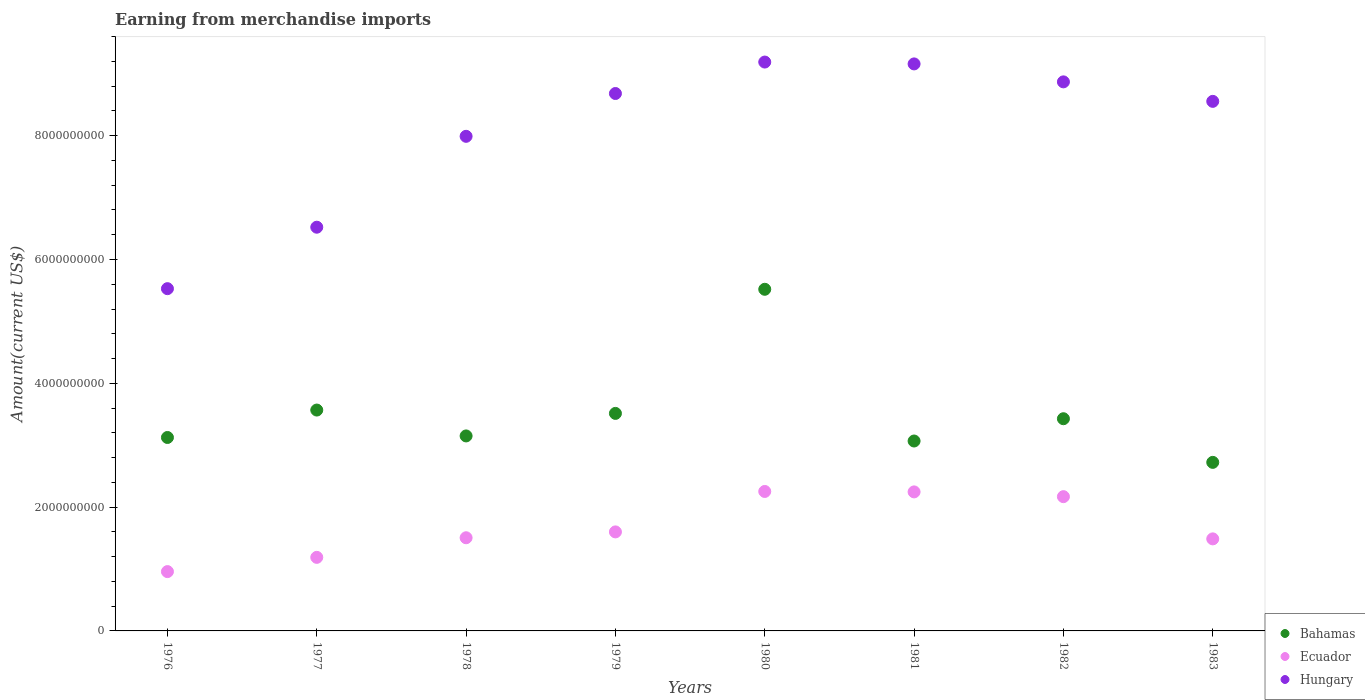What is the amount earned from merchandise imports in Ecuador in 1978?
Your response must be concise. 1.51e+09. Across all years, what is the maximum amount earned from merchandise imports in Hungary?
Offer a terse response. 9.19e+09. Across all years, what is the minimum amount earned from merchandise imports in Ecuador?
Provide a short and direct response. 9.58e+08. In which year was the amount earned from merchandise imports in Hungary maximum?
Your answer should be compact. 1980. In which year was the amount earned from merchandise imports in Hungary minimum?
Keep it short and to the point. 1976. What is the total amount earned from merchandise imports in Hungary in the graph?
Your answer should be very brief. 6.45e+1. What is the difference between the amount earned from merchandise imports in Hungary in 1979 and that in 1982?
Your answer should be very brief. -1.88e+08. What is the difference between the amount earned from merchandise imports in Ecuador in 1979 and the amount earned from merchandise imports in Hungary in 1983?
Your answer should be compact. -6.96e+09. What is the average amount earned from merchandise imports in Bahamas per year?
Ensure brevity in your answer.  3.51e+09. In the year 1979, what is the difference between the amount earned from merchandise imports in Ecuador and amount earned from merchandise imports in Bahamas?
Keep it short and to the point. -1.91e+09. In how many years, is the amount earned from merchandise imports in Ecuador greater than 4000000000 US$?
Ensure brevity in your answer.  0. What is the ratio of the amount earned from merchandise imports in Bahamas in 1980 to that in 1983?
Keep it short and to the point. 2.03. Is the amount earned from merchandise imports in Bahamas in 1976 less than that in 1983?
Your answer should be compact. No. Is the difference between the amount earned from merchandise imports in Ecuador in 1977 and 1978 greater than the difference between the amount earned from merchandise imports in Bahamas in 1977 and 1978?
Give a very brief answer. No. What is the difference between the highest and the second highest amount earned from merchandise imports in Hungary?
Your response must be concise. 3.00e+07. What is the difference between the highest and the lowest amount earned from merchandise imports in Hungary?
Ensure brevity in your answer.  3.66e+09. Is the sum of the amount earned from merchandise imports in Hungary in 1981 and 1983 greater than the maximum amount earned from merchandise imports in Ecuador across all years?
Your response must be concise. Yes. Is the amount earned from merchandise imports in Bahamas strictly less than the amount earned from merchandise imports in Hungary over the years?
Provide a short and direct response. Yes. How many dotlines are there?
Give a very brief answer. 3. What is the difference between two consecutive major ticks on the Y-axis?
Your response must be concise. 2.00e+09. Are the values on the major ticks of Y-axis written in scientific E-notation?
Provide a short and direct response. No. Where does the legend appear in the graph?
Your response must be concise. Bottom right. How are the legend labels stacked?
Provide a succinct answer. Vertical. What is the title of the graph?
Keep it short and to the point. Earning from merchandise imports. What is the label or title of the Y-axis?
Your answer should be compact. Amount(current US$). What is the Amount(current US$) of Bahamas in 1976?
Make the answer very short. 3.12e+09. What is the Amount(current US$) of Ecuador in 1976?
Make the answer very short. 9.58e+08. What is the Amount(current US$) in Hungary in 1976?
Give a very brief answer. 5.53e+09. What is the Amount(current US$) of Bahamas in 1977?
Your answer should be very brief. 3.57e+09. What is the Amount(current US$) of Ecuador in 1977?
Your answer should be very brief. 1.19e+09. What is the Amount(current US$) in Hungary in 1977?
Your answer should be compact. 6.52e+09. What is the Amount(current US$) in Bahamas in 1978?
Your response must be concise. 3.15e+09. What is the Amount(current US$) of Ecuador in 1978?
Give a very brief answer. 1.51e+09. What is the Amount(current US$) in Hungary in 1978?
Keep it short and to the point. 7.99e+09. What is the Amount(current US$) of Bahamas in 1979?
Keep it short and to the point. 3.51e+09. What is the Amount(current US$) of Ecuador in 1979?
Give a very brief answer. 1.60e+09. What is the Amount(current US$) of Hungary in 1979?
Ensure brevity in your answer.  8.68e+09. What is the Amount(current US$) of Bahamas in 1980?
Your answer should be compact. 5.52e+09. What is the Amount(current US$) in Ecuador in 1980?
Offer a terse response. 2.25e+09. What is the Amount(current US$) in Hungary in 1980?
Your response must be concise. 9.19e+09. What is the Amount(current US$) in Bahamas in 1981?
Ensure brevity in your answer.  3.07e+09. What is the Amount(current US$) in Ecuador in 1981?
Keep it short and to the point. 2.25e+09. What is the Amount(current US$) in Hungary in 1981?
Your answer should be compact. 9.16e+09. What is the Amount(current US$) in Bahamas in 1982?
Your answer should be compact. 3.43e+09. What is the Amount(current US$) of Ecuador in 1982?
Keep it short and to the point. 2.17e+09. What is the Amount(current US$) in Hungary in 1982?
Ensure brevity in your answer.  8.87e+09. What is the Amount(current US$) of Bahamas in 1983?
Offer a very short reply. 2.72e+09. What is the Amount(current US$) of Ecuador in 1983?
Your answer should be very brief. 1.49e+09. What is the Amount(current US$) of Hungary in 1983?
Offer a very short reply. 8.56e+09. Across all years, what is the maximum Amount(current US$) of Bahamas?
Your answer should be very brief. 5.52e+09. Across all years, what is the maximum Amount(current US$) in Ecuador?
Provide a short and direct response. 2.25e+09. Across all years, what is the maximum Amount(current US$) in Hungary?
Offer a terse response. 9.19e+09. Across all years, what is the minimum Amount(current US$) of Bahamas?
Ensure brevity in your answer.  2.72e+09. Across all years, what is the minimum Amount(current US$) of Ecuador?
Offer a terse response. 9.58e+08. Across all years, what is the minimum Amount(current US$) of Hungary?
Your answer should be very brief. 5.53e+09. What is the total Amount(current US$) in Bahamas in the graph?
Your answer should be compact. 2.81e+1. What is the total Amount(current US$) in Ecuador in the graph?
Make the answer very short. 1.34e+1. What is the total Amount(current US$) in Hungary in the graph?
Your response must be concise. 6.45e+1. What is the difference between the Amount(current US$) of Bahamas in 1976 and that in 1977?
Provide a short and direct response. -4.43e+08. What is the difference between the Amount(current US$) of Ecuador in 1976 and that in 1977?
Give a very brief answer. -2.30e+08. What is the difference between the Amount(current US$) of Hungary in 1976 and that in 1977?
Your answer should be compact. -9.93e+08. What is the difference between the Amount(current US$) of Bahamas in 1976 and that in 1978?
Give a very brief answer. -2.50e+07. What is the difference between the Amount(current US$) of Ecuador in 1976 and that in 1978?
Give a very brief answer. -5.47e+08. What is the difference between the Amount(current US$) of Hungary in 1976 and that in 1978?
Give a very brief answer. -2.46e+09. What is the difference between the Amount(current US$) of Bahamas in 1976 and that in 1979?
Your answer should be very brief. -3.89e+08. What is the difference between the Amount(current US$) in Ecuador in 1976 and that in 1979?
Make the answer very short. -6.41e+08. What is the difference between the Amount(current US$) of Hungary in 1976 and that in 1979?
Your answer should be compact. -3.15e+09. What is the difference between the Amount(current US$) of Bahamas in 1976 and that in 1980?
Make the answer very short. -2.39e+09. What is the difference between the Amount(current US$) in Ecuador in 1976 and that in 1980?
Make the answer very short. -1.29e+09. What is the difference between the Amount(current US$) in Hungary in 1976 and that in 1980?
Your answer should be very brief. -3.66e+09. What is the difference between the Amount(current US$) of Bahamas in 1976 and that in 1981?
Your answer should be very brief. 5.70e+07. What is the difference between the Amount(current US$) in Ecuador in 1976 and that in 1981?
Your response must be concise. -1.29e+09. What is the difference between the Amount(current US$) of Hungary in 1976 and that in 1981?
Provide a succinct answer. -3.63e+09. What is the difference between the Amount(current US$) of Bahamas in 1976 and that in 1982?
Offer a very short reply. -3.03e+08. What is the difference between the Amount(current US$) in Ecuador in 1976 and that in 1982?
Make the answer very short. -1.21e+09. What is the difference between the Amount(current US$) in Hungary in 1976 and that in 1982?
Offer a terse response. -3.34e+09. What is the difference between the Amount(current US$) in Bahamas in 1976 and that in 1983?
Ensure brevity in your answer.  4.02e+08. What is the difference between the Amount(current US$) of Ecuador in 1976 and that in 1983?
Your answer should be very brief. -5.29e+08. What is the difference between the Amount(current US$) of Hungary in 1976 and that in 1983?
Keep it short and to the point. -3.03e+09. What is the difference between the Amount(current US$) in Bahamas in 1977 and that in 1978?
Keep it short and to the point. 4.18e+08. What is the difference between the Amount(current US$) of Ecuador in 1977 and that in 1978?
Keep it short and to the point. -3.17e+08. What is the difference between the Amount(current US$) of Hungary in 1977 and that in 1978?
Keep it short and to the point. -1.47e+09. What is the difference between the Amount(current US$) of Bahamas in 1977 and that in 1979?
Offer a very short reply. 5.40e+07. What is the difference between the Amount(current US$) of Ecuador in 1977 and that in 1979?
Ensure brevity in your answer.  -4.11e+08. What is the difference between the Amount(current US$) in Hungary in 1977 and that in 1979?
Your response must be concise. -2.16e+09. What is the difference between the Amount(current US$) of Bahamas in 1977 and that in 1980?
Offer a terse response. -1.95e+09. What is the difference between the Amount(current US$) of Ecuador in 1977 and that in 1980?
Keep it short and to the point. -1.06e+09. What is the difference between the Amount(current US$) of Hungary in 1977 and that in 1980?
Offer a terse response. -2.67e+09. What is the difference between the Amount(current US$) of Ecuador in 1977 and that in 1981?
Your response must be concise. -1.06e+09. What is the difference between the Amount(current US$) of Hungary in 1977 and that in 1981?
Your answer should be very brief. -2.64e+09. What is the difference between the Amount(current US$) in Bahamas in 1977 and that in 1982?
Offer a very short reply. 1.40e+08. What is the difference between the Amount(current US$) of Ecuador in 1977 and that in 1982?
Give a very brief answer. -9.80e+08. What is the difference between the Amount(current US$) in Hungary in 1977 and that in 1982?
Your response must be concise. -2.35e+09. What is the difference between the Amount(current US$) in Bahamas in 1977 and that in 1983?
Your answer should be very brief. 8.45e+08. What is the difference between the Amount(current US$) of Ecuador in 1977 and that in 1983?
Keep it short and to the point. -2.98e+08. What is the difference between the Amount(current US$) in Hungary in 1977 and that in 1983?
Offer a very short reply. -2.03e+09. What is the difference between the Amount(current US$) in Bahamas in 1978 and that in 1979?
Keep it short and to the point. -3.64e+08. What is the difference between the Amount(current US$) in Ecuador in 1978 and that in 1979?
Offer a very short reply. -9.46e+07. What is the difference between the Amount(current US$) of Hungary in 1978 and that in 1979?
Provide a short and direct response. -6.92e+08. What is the difference between the Amount(current US$) of Bahamas in 1978 and that in 1980?
Make the answer very short. -2.37e+09. What is the difference between the Amount(current US$) of Ecuador in 1978 and that in 1980?
Provide a succinct answer. -7.48e+08. What is the difference between the Amount(current US$) of Hungary in 1978 and that in 1980?
Your response must be concise. -1.20e+09. What is the difference between the Amount(current US$) of Bahamas in 1978 and that in 1981?
Offer a terse response. 8.20e+07. What is the difference between the Amount(current US$) of Ecuador in 1978 and that in 1981?
Your answer should be compact. -7.41e+08. What is the difference between the Amount(current US$) in Hungary in 1978 and that in 1981?
Provide a short and direct response. -1.17e+09. What is the difference between the Amount(current US$) in Bahamas in 1978 and that in 1982?
Your answer should be compact. -2.78e+08. What is the difference between the Amount(current US$) in Ecuador in 1978 and that in 1982?
Give a very brief answer. -6.64e+08. What is the difference between the Amount(current US$) of Hungary in 1978 and that in 1982?
Provide a succinct answer. -8.80e+08. What is the difference between the Amount(current US$) in Bahamas in 1978 and that in 1983?
Ensure brevity in your answer.  4.27e+08. What is the difference between the Amount(current US$) of Ecuador in 1978 and that in 1983?
Keep it short and to the point. 1.81e+07. What is the difference between the Amount(current US$) in Hungary in 1978 and that in 1983?
Provide a succinct answer. -5.65e+08. What is the difference between the Amount(current US$) in Bahamas in 1979 and that in 1980?
Make the answer very short. -2.00e+09. What is the difference between the Amount(current US$) in Ecuador in 1979 and that in 1980?
Provide a succinct answer. -6.53e+08. What is the difference between the Amount(current US$) of Hungary in 1979 and that in 1980?
Make the answer very short. -5.08e+08. What is the difference between the Amount(current US$) in Bahamas in 1979 and that in 1981?
Your answer should be compact. 4.46e+08. What is the difference between the Amount(current US$) of Ecuador in 1979 and that in 1981?
Your answer should be very brief. -6.46e+08. What is the difference between the Amount(current US$) in Hungary in 1979 and that in 1981?
Your answer should be compact. -4.78e+08. What is the difference between the Amount(current US$) in Bahamas in 1979 and that in 1982?
Make the answer very short. 8.60e+07. What is the difference between the Amount(current US$) of Ecuador in 1979 and that in 1982?
Offer a terse response. -5.69e+08. What is the difference between the Amount(current US$) in Hungary in 1979 and that in 1982?
Make the answer very short. -1.88e+08. What is the difference between the Amount(current US$) in Bahamas in 1979 and that in 1983?
Your response must be concise. 7.91e+08. What is the difference between the Amount(current US$) of Ecuador in 1979 and that in 1983?
Your response must be concise. 1.13e+08. What is the difference between the Amount(current US$) in Hungary in 1979 and that in 1983?
Give a very brief answer. 1.27e+08. What is the difference between the Amount(current US$) in Bahamas in 1980 and that in 1981?
Provide a succinct answer. 2.45e+09. What is the difference between the Amount(current US$) of Hungary in 1980 and that in 1981?
Offer a very short reply. 3.00e+07. What is the difference between the Amount(current US$) of Bahamas in 1980 and that in 1982?
Make the answer very short. 2.09e+09. What is the difference between the Amount(current US$) in Ecuador in 1980 and that in 1982?
Offer a terse response. 8.40e+07. What is the difference between the Amount(current US$) of Hungary in 1980 and that in 1982?
Offer a very short reply. 3.20e+08. What is the difference between the Amount(current US$) in Bahamas in 1980 and that in 1983?
Your response must be concise. 2.80e+09. What is the difference between the Amount(current US$) of Ecuador in 1980 and that in 1983?
Provide a short and direct response. 7.66e+08. What is the difference between the Amount(current US$) of Hungary in 1980 and that in 1983?
Your answer should be very brief. 6.35e+08. What is the difference between the Amount(current US$) in Bahamas in 1981 and that in 1982?
Offer a terse response. -3.60e+08. What is the difference between the Amount(current US$) of Ecuador in 1981 and that in 1982?
Offer a terse response. 7.70e+07. What is the difference between the Amount(current US$) of Hungary in 1981 and that in 1982?
Your answer should be compact. 2.90e+08. What is the difference between the Amount(current US$) in Bahamas in 1981 and that in 1983?
Offer a very short reply. 3.45e+08. What is the difference between the Amount(current US$) of Ecuador in 1981 and that in 1983?
Ensure brevity in your answer.  7.59e+08. What is the difference between the Amount(current US$) of Hungary in 1981 and that in 1983?
Your answer should be compact. 6.05e+08. What is the difference between the Amount(current US$) in Bahamas in 1982 and that in 1983?
Your answer should be very brief. 7.05e+08. What is the difference between the Amount(current US$) in Ecuador in 1982 and that in 1983?
Offer a very short reply. 6.82e+08. What is the difference between the Amount(current US$) in Hungary in 1982 and that in 1983?
Your answer should be compact. 3.15e+08. What is the difference between the Amount(current US$) in Bahamas in 1976 and the Amount(current US$) in Ecuador in 1977?
Your response must be concise. 1.94e+09. What is the difference between the Amount(current US$) in Bahamas in 1976 and the Amount(current US$) in Hungary in 1977?
Make the answer very short. -3.40e+09. What is the difference between the Amount(current US$) in Ecuador in 1976 and the Amount(current US$) in Hungary in 1977?
Your answer should be very brief. -5.56e+09. What is the difference between the Amount(current US$) of Bahamas in 1976 and the Amount(current US$) of Ecuador in 1978?
Keep it short and to the point. 1.62e+09. What is the difference between the Amount(current US$) of Bahamas in 1976 and the Amount(current US$) of Hungary in 1978?
Your answer should be very brief. -4.87e+09. What is the difference between the Amount(current US$) in Ecuador in 1976 and the Amount(current US$) in Hungary in 1978?
Keep it short and to the point. -7.03e+09. What is the difference between the Amount(current US$) of Bahamas in 1976 and the Amount(current US$) of Ecuador in 1979?
Make the answer very short. 1.53e+09. What is the difference between the Amount(current US$) in Bahamas in 1976 and the Amount(current US$) in Hungary in 1979?
Offer a very short reply. -5.56e+09. What is the difference between the Amount(current US$) in Ecuador in 1976 and the Amount(current US$) in Hungary in 1979?
Provide a succinct answer. -7.72e+09. What is the difference between the Amount(current US$) in Bahamas in 1976 and the Amount(current US$) in Ecuador in 1980?
Provide a succinct answer. 8.72e+08. What is the difference between the Amount(current US$) of Bahamas in 1976 and the Amount(current US$) of Hungary in 1980?
Your answer should be very brief. -6.06e+09. What is the difference between the Amount(current US$) of Ecuador in 1976 and the Amount(current US$) of Hungary in 1980?
Your answer should be very brief. -8.23e+09. What is the difference between the Amount(current US$) in Bahamas in 1976 and the Amount(current US$) in Ecuador in 1981?
Give a very brief answer. 8.79e+08. What is the difference between the Amount(current US$) in Bahamas in 1976 and the Amount(current US$) in Hungary in 1981?
Provide a short and direct response. -6.04e+09. What is the difference between the Amount(current US$) in Ecuador in 1976 and the Amount(current US$) in Hungary in 1981?
Provide a short and direct response. -8.20e+09. What is the difference between the Amount(current US$) in Bahamas in 1976 and the Amount(current US$) in Ecuador in 1982?
Your answer should be compact. 9.56e+08. What is the difference between the Amount(current US$) in Bahamas in 1976 and the Amount(current US$) in Hungary in 1982?
Your answer should be compact. -5.74e+09. What is the difference between the Amount(current US$) of Ecuador in 1976 and the Amount(current US$) of Hungary in 1982?
Make the answer very short. -7.91e+09. What is the difference between the Amount(current US$) in Bahamas in 1976 and the Amount(current US$) in Ecuador in 1983?
Ensure brevity in your answer.  1.64e+09. What is the difference between the Amount(current US$) in Bahamas in 1976 and the Amount(current US$) in Hungary in 1983?
Make the answer very short. -5.43e+09. What is the difference between the Amount(current US$) in Ecuador in 1976 and the Amount(current US$) in Hungary in 1983?
Your answer should be very brief. -7.60e+09. What is the difference between the Amount(current US$) of Bahamas in 1977 and the Amount(current US$) of Ecuador in 1978?
Provide a short and direct response. 2.06e+09. What is the difference between the Amount(current US$) of Bahamas in 1977 and the Amount(current US$) of Hungary in 1978?
Ensure brevity in your answer.  -4.42e+09. What is the difference between the Amount(current US$) of Ecuador in 1977 and the Amount(current US$) of Hungary in 1978?
Offer a very short reply. -6.80e+09. What is the difference between the Amount(current US$) of Bahamas in 1977 and the Amount(current US$) of Ecuador in 1979?
Provide a short and direct response. 1.97e+09. What is the difference between the Amount(current US$) in Bahamas in 1977 and the Amount(current US$) in Hungary in 1979?
Ensure brevity in your answer.  -5.11e+09. What is the difference between the Amount(current US$) of Ecuador in 1977 and the Amount(current US$) of Hungary in 1979?
Make the answer very short. -7.49e+09. What is the difference between the Amount(current US$) of Bahamas in 1977 and the Amount(current US$) of Ecuador in 1980?
Your answer should be very brief. 1.32e+09. What is the difference between the Amount(current US$) of Bahamas in 1977 and the Amount(current US$) of Hungary in 1980?
Your response must be concise. -5.62e+09. What is the difference between the Amount(current US$) of Ecuador in 1977 and the Amount(current US$) of Hungary in 1980?
Keep it short and to the point. -8.00e+09. What is the difference between the Amount(current US$) of Bahamas in 1977 and the Amount(current US$) of Ecuador in 1981?
Your answer should be very brief. 1.32e+09. What is the difference between the Amount(current US$) of Bahamas in 1977 and the Amount(current US$) of Hungary in 1981?
Ensure brevity in your answer.  -5.59e+09. What is the difference between the Amount(current US$) of Ecuador in 1977 and the Amount(current US$) of Hungary in 1981?
Make the answer very short. -7.97e+09. What is the difference between the Amount(current US$) in Bahamas in 1977 and the Amount(current US$) in Ecuador in 1982?
Provide a short and direct response. 1.40e+09. What is the difference between the Amount(current US$) in Bahamas in 1977 and the Amount(current US$) in Hungary in 1982?
Your answer should be very brief. -5.30e+09. What is the difference between the Amount(current US$) in Ecuador in 1977 and the Amount(current US$) in Hungary in 1982?
Make the answer very short. -7.68e+09. What is the difference between the Amount(current US$) of Bahamas in 1977 and the Amount(current US$) of Ecuador in 1983?
Provide a short and direct response. 2.08e+09. What is the difference between the Amount(current US$) in Bahamas in 1977 and the Amount(current US$) in Hungary in 1983?
Ensure brevity in your answer.  -4.99e+09. What is the difference between the Amount(current US$) of Ecuador in 1977 and the Amount(current US$) of Hungary in 1983?
Make the answer very short. -7.37e+09. What is the difference between the Amount(current US$) in Bahamas in 1978 and the Amount(current US$) in Ecuador in 1979?
Your answer should be very brief. 1.55e+09. What is the difference between the Amount(current US$) in Bahamas in 1978 and the Amount(current US$) in Hungary in 1979?
Provide a succinct answer. -5.53e+09. What is the difference between the Amount(current US$) of Ecuador in 1978 and the Amount(current US$) of Hungary in 1979?
Ensure brevity in your answer.  -7.18e+09. What is the difference between the Amount(current US$) in Bahamas in 1978 and the Amount(current US$) in Ecuador in 1980?
Offer a terse response. 8.97e+08. What is the difference between the Amount(current US$) of Bahamas in 1978 and the Amount(current US$) of Hungary in 1980?
Provide a short and direct response. -6.04e+09. What is the difference between the Amount(current US$) of Ecuador in 1978 and the Amount(current US$) of Hungary in 1980?
Provide a short and direct response. -7.68e+09. What is the difference between the Amount(current US$) of Bahamas in 1978 and the Amount(current US$) of Ecuador in 1981?
Keep it short and to the point. 9.04e+08. What is the difference between the Amount(current US$) in Bahamas in 1978 and the Amount(current US$) in Hungary in 1981?
Make the answer very short. -6.01e+09. What is the difference between the Amount(current US$) of Ecuador in 1978 and the Amount(current US$) of Hungary in 1981?
Provide a succinct answer. -7.65e+09. What is the difference between the Amount(current US$) of Bahamas in 1978 and the Amount(current US$) of Ecuador in 1982?
Give a very brief answer. 9.81e+08. What is the difference between the Amount(current US$) of Bahamas in 1978 and the Amount(current US$) of Hungary in 1982?
Your response must be concise. -5.72e+09. What is the difference between the Amount(current US$) in Ecuador in 1978 and the Amount(current US$) in Hungary in 1982?
Your answer should be compact. -7.36e+09. What is the difference between the Amount(current US$) of Bahamas in 1978 and the Amount(current US$) of Ecuador in 1983?
Offer a very short reply. 1.66e+09. What is the difference between the Amount(current US$) of Bahamas in 1978 and the Amount(current US$) of Hungary in 1983?
Provide a succinct answer. -5.40e+09. What is the difference between the Amount(current US$) in Ecuador in 1978 and the Amount(current US$) in Hungary in 1983?
Provide a succinct answer. -7.05e+09. What is the difference between the Amount(current US$) in Bahamas in 1979 and the Amount(current US$) in Ecuador in 1980?
Provide a short and direct response. 1.26e+09. What is the difference between the Amount(current US$) in Bahamas in 1979 and the Amount(current US$) in Hungary in 1980?
Your response must be concise. -5.68e+09. What is the difference between the Amount(current US$) of Ecuador in 1979 and the Amount(current US$) of Hungary in 1980?
Your answer should be very brief. -7.59e+09. What is the difference between the Amount(current US$) in Bahamas in 1979 and the Amount(current US$) in Ecuador in 1981?
Your answer should be very brief. 1.27e+09. What is the difference between the Amount(current US$) of Bahamas in 1979 and the Amount(current US$) of Hungary in 1981?
Provide a succinct answer. -5.65e+09. What is the difference between the Amount(current US$) in Ecuador in 1979 and the Amount(current US$) in Hungary in 1981?
Make the answer very short. -7.56e+09. What is the difference between the Amount(current US$) in Bahamas in 1979 and the Amount(current US$) in Ecuador in 1982?
Provide a short and direct response. 1.34e+09. What is the difference between the Amount(current US$) of Bahamas in 1979 and the Amount(current US$) of Hungary in 1982?
Keep it short and to the point. -5.36e+09. What is the difference between the Amount(current US$) in Ecuador in 1979 and the Amount(current US$) in Hungary in 1982?
Keep it short and to the point. -7.27e+09. What is the difference between the Amount(current US$) in Bahamas in 1979 and the Amount(current US$) in Ecuador in 1983?
Make the answer very short. 2.03e+09. What is the difference between the Amount(current US$) of Bahamas in 1979 and the Amount(current US$) of Hungary in 1983?
Ensure brevity in your answer.  -5.04e+09. What is the difference between the Amount(current US$) in Ecuador in 1979 and the Amount(current US$) in Hungary in 1983?
Your answer should be compact. -6.96e+09. What is the difference between the Amount(current US$) in Bahamas in 1980 and the Amount(current US$) in Ecuador in 1981?
Offer a terse response. 3.27e+09. What is the difference between the Amount(current US$) of Bahamas in 1980 and the Amount(current US$) of Hungary in 1981?
Make the answer very short. -3.64e+09. What is the difference between the Amount(current US$) of Ecuador in 1980 and the Amount(current US$) of Hungary in 1981?
Offer a terse response. -6.91e+09. What is the difference between the Amount(current US$) of Bahamas in 1980 and the Amount(current US$) of Ecuador in 1982?
Offer a terse response. 3.35e+09. What is the difference between the Amount(current US$) in Bahamas in 1980 and the Amount(current US$) in Hungary in 1982?
Ensure brevity in your answer.  -3.35e+09. What is the difference between the Amount(current US$) in Ecuador in 1980 and the Amount(current US$) in Hungary in 1982?
Make the answer very short. -6.62e+09. What is the difference between the Amount(current US$) of Bahamas in 1980 and the Amount(current US$) of Ecuador in 1983?
Ensure brevity in your answer.  4.03e+09. What is the difference between the Amount(current US$) of Bahamas in 1980 and the Amount(current US$) of Hungary in 1983?
Your response must be concise. -3.04e+09. What is the difference between the Amount(current US$) of Ecuador in 1980 and the Amount(current US$) of Hungary in 1983?
Offer a very short reply. -6.30e+09. What is the difference between the Amount(current US$) of Bahamas in 1981 and the Amount(current US$) of Ecuador in 1982?
Make the answer very short. 8.99e+08. What is the difference between the Amount(current US$) of Bahamas in 1981 and the Amount(current US$) of Hungary in 1982?
Offer a very short reply. -5.80e+09. What is the difference between the Amount(current US$) in Ecuador in 1981 and the Amount(current US$) in Hungary in 1982?
Provide a succinct answer. -6.62e+09. What is the difference between the Amount(current US$) of Bahamas in 1981 and the Amount(current US$) of Ecuador in 1983?
Ensure brevity in your answer.  1.58e+09. What is the difference between the Amount(current US$) in Bahamas in 1981 and the Amount(current US$) in Hungary in 1983?
Offer a terse response. -5.49e+09. What is the difference between the Amount(current US$) of Ecuador in 1981 and the Amount(current US$) of Hungary in 1983?
Provide a short and direct response. -6.31e+09. What is the difference between the Amount(current US$) in Bahamas in 1982 and the Amount(current US$) in Ecuador in 1983?
Your answer should be very brief. 1.94e+09. What is the difference between the Amount(current US$) in Bahamas in 1982 and the Amount(current US$) in Hungary in 1983?
Provide a succinct answer. -5.13e+09. What is the difference between the Amount(current US$) in Ecuador in 1982 and the Amount(current US$) in Hungary in 1983?
Give a very brief answer. -6.39e+09. What is the average Amount(current US$) in Bahamas per year?
Provide a short and direct response. 3.51e+09. What is the average Amount(current US$) in Ecuador per year?
Give a very brief answer. 1.68e+09. What is the average Amount(current US$) of Hungary per year?
Provide a succinct answer. 8.06e+09. In the year 1976, what is the difference between the Amount(current US$) in Bahamas and Amount(current US$) in Ecuador?
Offer a very short reply. 2.17e+09. In the year 1976, what is the difference between the Amount(current US$) of Bahamas and Amount(current US$) of Hungary?
Provide a short and direct response. -2.40e+09. In the year 1976, what is the difference between the Amount(current US$) in Ecuador and Amount(current US$) in Hungary?
Give a very brief answer. -4.57e+09. In the year 1977, what is the difference between the Amount(current US$) of Bahamas and Amount(current US$) of Ecuador?
Keep it short and to the point. 2.38e+09. In the year 1977, what is the difference between the Amount(current US$) of Bahamas and Amount(current US$) of Hungary?
Give a very brief answer. -2.95e+09. In the year 1977, what is the difference between the Amount(current US$) of Ecuador and Amount(current US$) of Hungary?
Your response must be concise. -5.33e+09. In the year 1978, what is the difference between the Amount(current US$) of Bahamas and Amount(current US$) of Ecuador?
Offer a terse response. 1.64e+09. In the year 1978, what is the difference between the Amount(current US$) of Bahamas and Amount(current US$) of Hungary?
Offer a very short reply. -4.84e+09. In the year 1978, what is the difference between the Amount(current US$) in Ecuador and Amount(current US$) in Hungary?
Offer a very short reply. -6.49e+09. In the year 1979, what is the difference between the Amount(current US$) in Bahamas and Amount(current US$) in Ecuador?
Provide a succinct answer. 1.91e+09. In the year 1979, what is the difference between the Amount(current US$) of Bahamas and Amount(current US$) of Hungary?
Your answer should be very brief. -5.17e+09. In the year 1979, what is the difference between the Amount(current US$) of Ecuador and Amount(current US$) of Hungary?
Provide a short and direct response. -7.08e+09. In the year 1980, what is the difference between the Amount(current US$) in Bahamas and Amount(current US$) in Ecuador?
Offer a terse response. 3.27e+09. In the year 1980, what is the difference between the Amount(current US$) in Bahamas and Amount(current US$) in Hungary?
Your response must be concise. -3.67e+09. In the year 1980, what is the difference between the Amount(current US$) of Ecuador and Amount(current US$) of Hungary?
Provide a succinct answer. -6.94e+09. In the year 1981, what is the difference between the Amount(current US$) in Bahamas and Amount(current US$) in Ecuador?
Offer a very short reply. 8.22e+08. In the year 1981, what is the difference between the Amount(current US$) in Bahamas and Amount(current US$) in Hungary?
Make the answer very short. -6.09e+09. In the year 1981, what is the difference between the Amount(current US$) in Ecuador and Amount(current US$) in Hungary?
Your response must be concise. -6.91e+09. In the year 1982, what is the difference between the Amount(current US$) in Bahamas and Amount(current US$) in Ecuador?
Your answer should be compact. 1.26e+09. In the year 1982, what is the difference between the Amount(current US$) of Bahamas and Amount(current US$) of Hungary?
Provide a succinct answer. -5.44e+09. In the year 1982, what is the difference between the Amount(current US$) in Ecuador and Amount(current US$) in Hungary?
Make the answer very short. -6.70e+09. In the year 1983, what is the difference between the Amount(current US$) of Bahamas and Amount(current US$) of Ecuador?
Your answer should be very brief. 1.24e+09. In the year 1983, what is the difference between the Amount(current US$) of Bahamas and Amount(current US$) of Hungary?
Your answer should be compact. -5.83e+09. In the year 1983, what is the difference between the Amount(current US$) in Ecuador and Amount(current US$) in Hungary?
Make the answer very short. -7.07e+09. What is the ratio of the Amount(current US$) of Bahamas in 1976 to that in 1977?
Ensure brevity in your answer.  0.88. What is the ratio of the Amount(current US$) of Ecuador in 1976 to that in 1977?
Provide a short and direct response. 0.81. What is the ratio of the Amount(current US$) in Hungary in 1976 to that in 1977?
Your answer should be very brief. 0.85. What is the ratio of the Amount(current US$) in Ecuador in 1976 to that in 1978?
Ensure brevity in your answer.  0.64. What is the ratio of the Amount(current US$) of Hungary in 1976 to that in 1978?
Ensure brevity in your answer.  0.69. What is the ratio of the Amount(current US$) in Bahamas in 1976 to that in 1979?
Give a very brief answer. 0.89. What is the ratio of the Amount(current US$) in Ecuador in 1976 to that in 1979?
Your response must be concise. 0.6. What is the ratio of the Amount(current US$) in Hungary in 1976 to that in 1979?
Your answer should be very brief. 0.64. What is the ratio of the Amount(current US$) in Bahamas in 1976 to that in 1980?
Your response must be concise. 0.57. What is the ratio of the Amount(current US$) in Ecuador in 1976 to that in 1980?
Your answer should be compact. 0.43. What is the ratio of the Amount(current US$) in Hungary in 1976 to that in 1980?
Your answer should be compact. 0.6. What is the ratio of the Amount(current US$) in Bahamas in 1976 to that in 1981?
Provide a succinct answer. 1.02. What is the ratio of the Amount(current US$) of Ecuador in 1976 to that in 1981?
Make the answer very short. 0.43. What is the ratio of the Amount(current US$) of Hungary in 1976 to that in 1981?
Provide a succinct answer. 0.6. What is the ratio of the Amount(current US$) in Bahamas in 1976 to that in 1982?
Your answer should be very brief. 0.91. What is the ratio of the Amount(current US$) of Ecuador in 1976 to that in 1982?
Provide a short and direct response. 0.44. What is the ratio of the Amount(current US$) in Hungary in 1976 to that in 1982?
Ensure brevity in your answer.  0.62. What is the ratio of the Amount(current US$) in Bahamas in 1976 to that in 1983?
Your answer should be compact. 1.15. What is the ratio of the Amount(current US$) of Ecuador in 1976 to that in 1983?
Provide a succinct answer. 0.64. What is the ratio of the Amount(current US$) of Hungary in 1976 to that in 1983?
Provide a short and direct response. 0.65. What is the ratio of the Amount(current US$) in Bahamas in 1977 to that in 1978?
Make the answer very short. 1.13. What is the ratio of the Amount(current US$) in Ecuador in 1977 to that in 1978?
Provide a short and direct response. 0.79. What is the ratio of the Amount(current US$) of Hungary in 1977 to that in 1978?
Make the answer very short. 0.82. What is the ratio of the Amount(current US$) of Bahamas in 1977 to that in 1979?
Keep it short and to the point. 1.02. What is the ratio of the Amount(current US$) in Ecuador in 1977 to that in 1979?
Give a very brief answer. 0.74. What is the ratio of the Amount(current US$) of Hungary in 1977 to that in 1979?
Provide a short and direct response. 0.75. What is the ratio of the Amount(current US$) in Bahamas in 1977 to that in 1980?
Provide a succinct answer. 0.65. What is the ratio of the Amount(current US$) of Ecuador in 1977 to that in 1980?
Your answer should be compact. 0.53. What is the ratio of the Amount(current US$) in Hungary in 1977 to that in 1980?
Keep it short and to the point. 0.71. What is the ratio of the Amount(current US$) in Bahamas in 1977 to that in 1981?
Your response must be concise. 1.16. What is the ratio of the Amount(current US$) in Ecuador in 1977 to that in 1981?
Offer a very short reply. 0.53. What is the ratio of the Amount(current US$) in Hungary in 1977 to that in 1981?
Offer a very short reply. 0.71. What is the ratio of the Amount(current US$) in Bahamas in 1977 to that in 1982?
Your answer should be compact. 1.04. What is the ratio of the Amount(current US$) of Ecuador in 1977 to that in 1982?
Keep it short and to the point. 0.55. What is the ratio of the Amount(current US$) in Hungary in 1977 to that in 1982?
Your answer should be very brief. 0.74. What is the ratio of the Amount(current US$) in Bahamas in 1977 to that in 1983?
Your answer should be compact. 1.31. What is the ratio of the Amount(current US$) in Ecuador in 1977 to that in 1983?
Your answer should be very brief. 0.8. What is the ratio of the Amount(current US$) in Hungary in 1977 to that in 1983?
Keep it short and to the point. 0.76. What is the ratio of the Amount(current US$) of Bahamas in 1978 to that in 1979?
Your response must be concise. 0.9. What is the ratio of the Amount(current US$) of Ecuador in 1978 to that in 1979?
Your answer should be compact. 0.94. What is the ratio of the Amount(current US$) in Hungary in 1978 to that in 1979?
Offer a very short reply. 0.92. What is the ratio of the Amount(current US$) of Bahamas in 1978 to that in 1980?
Give a very brief answer. 0.57. What is the ratio of the Amount(current US$) of Ecuador in 1978 to that in 1980?
Offer a terse response. 0.67. What is the ratio of the Amount(current US$) of Hungary in 1978 to that in 1980?
Your response must be concise. 0.87. What is the ratio of the Amount(current US$) of Bahamas in 1978 to that in 1981?
Make the answer very short. 1.03. What is the ratio of the Amount(current US$) of Ecuador in 1978 to that in 1981?
Your answer should be compact. 0.67. What is the ratio of the Amount(current US$) of Hungary in 1978 to that in 1981?
Ensure brevity in your answer.  0.87. What is the ratio of the Amount(current US$) of Bahamas in 1978 to that in 1982?
Keep it short and to the point. 0.92. What is the ratio of the Amount(current US$) in Ecuador in 1978 to that in 1982?
Your answer should be compact. 0.69. What is the ratio of the Amount(current US$) of Hungary in 1978 to that in 1982?
Offer a very short reply. 0.9. What is the ratio of the Amount(current US$) of Bahamas in 1978 to that in 1983?
Offer a very short reply. 1.16. What is the ratio of the Amount(current US$) of Ecuador in 1978 to that in 1983?
Offer a very short reply. 1.01. What is the ratio of the Amount(current US$) of Hungary in 1978 to that in 1983?
Offer a very short reply. 0.93. What is the ratio of the Amount(current US$) of Bahamas in 1979 to that in 1980?
Your answer should be compact. 0.64. What is the ratio of the Amount(current US$) of Ecuador in 1979 to that in 1980?
Your answer should be very brief. 0.71. What is the ratio of the Amount(current US$) in Hungary in 1979 to that in 1980?
Offer a terse response. 0.94. What is the ratio of the Amount(current US$) in Bahamas in 1979 to that in 1981?
Your response must be concise. 1.15. What is the ratio of the Amount(current US$) in Ecuador in 1979 to that in 1981?
Your answer should be compact. 0.71. What is the ratio of the Amount(current US$) in Hungary in 1979 to that in 1981?
Offer a terse response. 0.95. What is the ratio of the Amount(current US$) in Bahamas in 1979 to that in 1982?
Provide a succinct answer. 1.03. What is the ratio of the Amount(current US$) of Ecuador in 1979 to that in 1982?
Make the answer very short. 0.74. What is the ratio of the Amount(current US$) of Hungary in 1979 to that in 1982?
Provide a succinct answer. 0.98. What is the ratio of the Amount(current US$) of Bahamas in 1979 to that in 1983?
Provide a succinct answer. 1.29. What is the ratio of the Amount(current US$) of Ecuador in 1979 to that in 1983?
Provide a succinct answer. 1.08. What is the ratio of the Amount(current US$) in Hungary in 1979 to that in 1983?
Give a very brief answer. 1.01. What is the ratio of the Amount(current US$) in Bahamas in 1980 to that in 1981?
Offer a terse response. 1.8. What is the ratio of the Amount(current US$) of Hungary in 1980 to that in 1981?
Provide a succinct answer. 1. What is the ratio of the Amount(current US$) in Bahamas in 1980 to that in 1982?
Make the answer very short. 1.61. What is the ratio of the Amount(current US$) of Ecuador in 1980 to that in 1982?
Keep it short and to the point. 1.04. What is the ratio of the Amount(current US$) of Hungary in 1980 to that in 1982?
Ensure brevity in your answer.  1.04. What is the ratio of the Amount(current US$) in Bahamas in 1980 to that in 1983?
Make the answer very short. 2.03. What is the ratio of the Amount(current US$) of Ecuador in 1980 to that in 1983?
Give a very brief answer. 1.52. What is the ratio of the Amount(current US$) in Hungary in 1980 to that in 1983?
Your answer should be very brief. 1.07. What is the ratio of the Amount(current US$) of Bahamas in 1981 to that in 1982?
Your answer should be compact. 0.9. What is the ratio of the Amount(current US$) of Ecuador in 1981 to that in 1982?
Give a very brief answer. 1.04. What is the ratio of the Amount(current US$) in Hungary in 1981 to that in 1982?
Provide a short and direct response. 1.03. What is the ratio of the Amount(current US$) in Bahamas in 1981 to that in 1983?
Offer a terse response. 1.13. What is the ratio of the Amount(current US$) of Ecuador in 1981 to that in 1983?
Offer a terse response. 1.51. What is the ratio of the Amount(current US$) in Hungary in 1981 to that in 1983?
Make the answer very short. 1.07. What is the ratio of the Amount(current US$) in Bahamas in 1982 to that in 1983?
Provide a short and direct response. 1.26. What is the ratio of the Amount(current US$) of Ecuador in 1982 to that in 1983?
Your answer should be very brief. 1.46. What is the ratio of the Amount(current US$) of Hungary in 1982 to that in 1983?
Keep it short and to the point. 1.04. What is the difference between the highest and the second highest Amount(current US$) in Bahamas?
Your answer should be compact. 1.95e+09. What is the difference between the highest and the second highest Amount(current US$) of Hungary?
Ensure brevity in your answer.  3.00e+07. What is the difference between the highest and the lowest Amount(current US$) in Bahamas?
Ensure brevity in your answer.  2.80e+09. What is the difference between the highest and the lowest Amount(current US$) of Ecuador?
Your response must be concise. 1.29e+09. What is the difference between the highest and the lowest Amount(current US$) of Hungary?
Ensure brevity in your answer.  3.66e+09. 